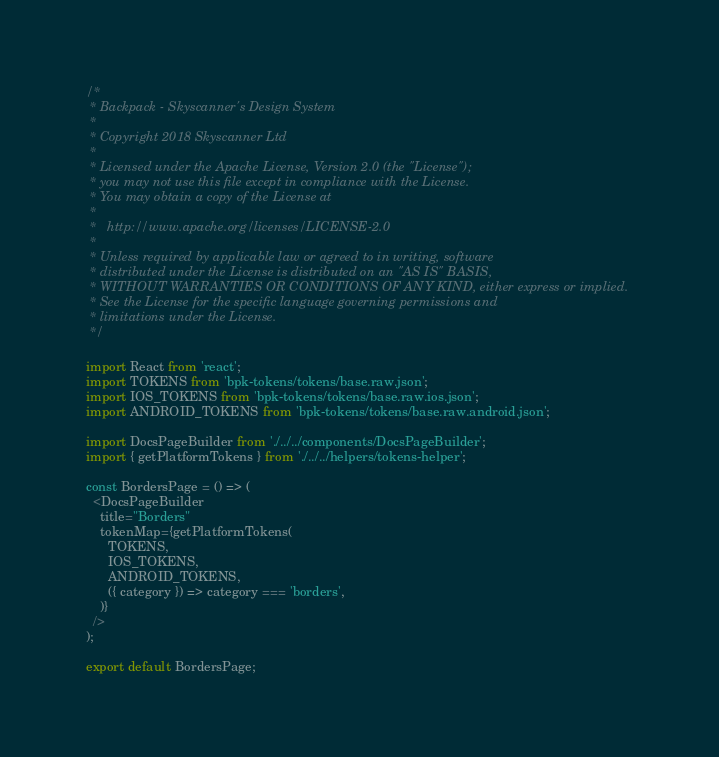Convert code to text. <code><loc_0><loc_0><loc_500><loc_500><_JavaScript_>/*
 * Backpack - Skyscanner's Design System
 *
 * Copyright 2018 Skyscanner Ltd
 *
 * Licensed under the Apache License, Version 2.0 (the "License");
 * you may not use this file except in compliance with the License.
 * You may obtain a copy of the License at
 *
 *   http://www.apache.org/licenses/LICENSE-2.0
 *
 * Unless required by applicable law or agreed to in writing, software
 * distributed under the License is distributed on an "AS IS" BASIS,
 * WITHOUT WARRANTIES OR CONDITIONS OF ANY KIND, either express or implied.
 * See the License for the specific language governing permissions and
 * limitations under the License.
 */

import React from 'react';
import TOKENS from 'bpk-tokens/tokens/base.raw.json';
import IOS_TOKENS from 'bpk-tokens/tokens/base.raw.ios.json';
import ANDROID_TOKENS from 'bpk-tokens/tokens/base.raw.android.json';

import DocsPageBuilder from './../../components/DocsPageBuilder';
import { getPlatformTokens } from './../../helpers/tokens-helper';

const BordersPage = () => (
  <DocsPageBuilder
    title="Borders"
    tokenMap={getPlatformTokens(
      TOKENS,
      IOS_TOKENS,
      ANDROID_TOKENS,
      ({ category }) => category === 'borders',
    )}
  />
);

export default BordersPage;
</code> 